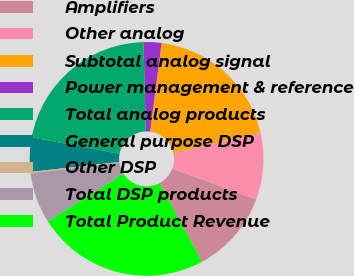Convert chart to OTSL. <chart><loc_0><loc_0><loc_500><loc_500><pie_chart><fcel>Amplifiers<fcel>Other analog<fcel>Subtotal analog signal<fcel>Power management & reference<fcel>Total analog products<fcel>General purpose DSP<fcel>Other DSP<fcel>Total DSP products<fcel>Total Product Revenue<nl><fcel>11.5%<fcel>9.24%<fcel>19.35%<fcel>2.48%<fcel>21.61%<fcel>4.74%<fcel>0.23%<fcel>6.99%<fcel>23.86%<nl></chart> 